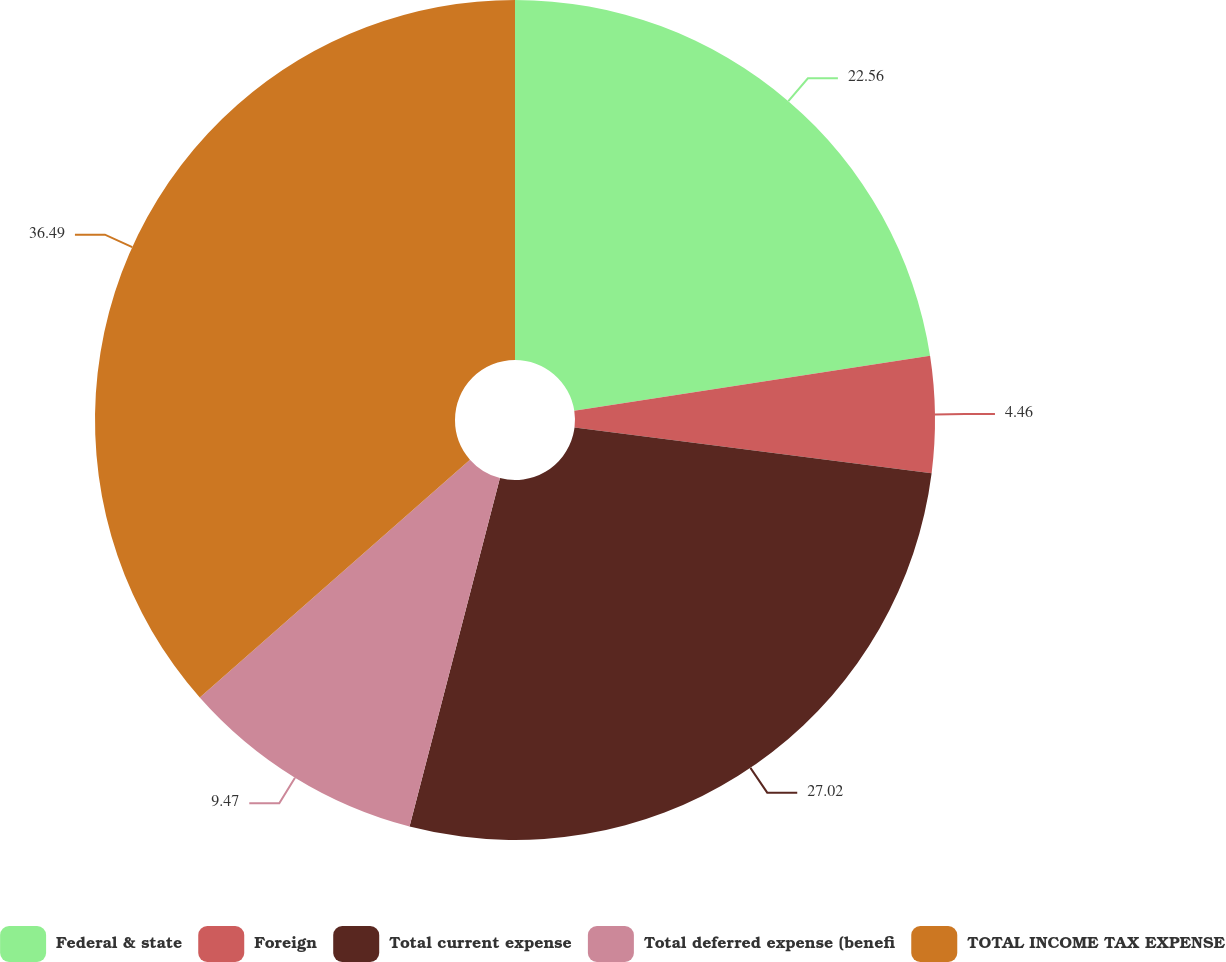<chart> <loc_0><loc_0><loc_500><loc_500><pie_chart><fcel>Federal & state<fcel>Foreign<fcel>Total current expense<fcel>Total deferred expense (benefi<fcel>TOTAL INCOME TAX EXPENSE<nl><fcel>22.56%<fcel>4.46%<fcel>27.02%<fcel>9.47%<fcel>36.49%<nl></chart> 